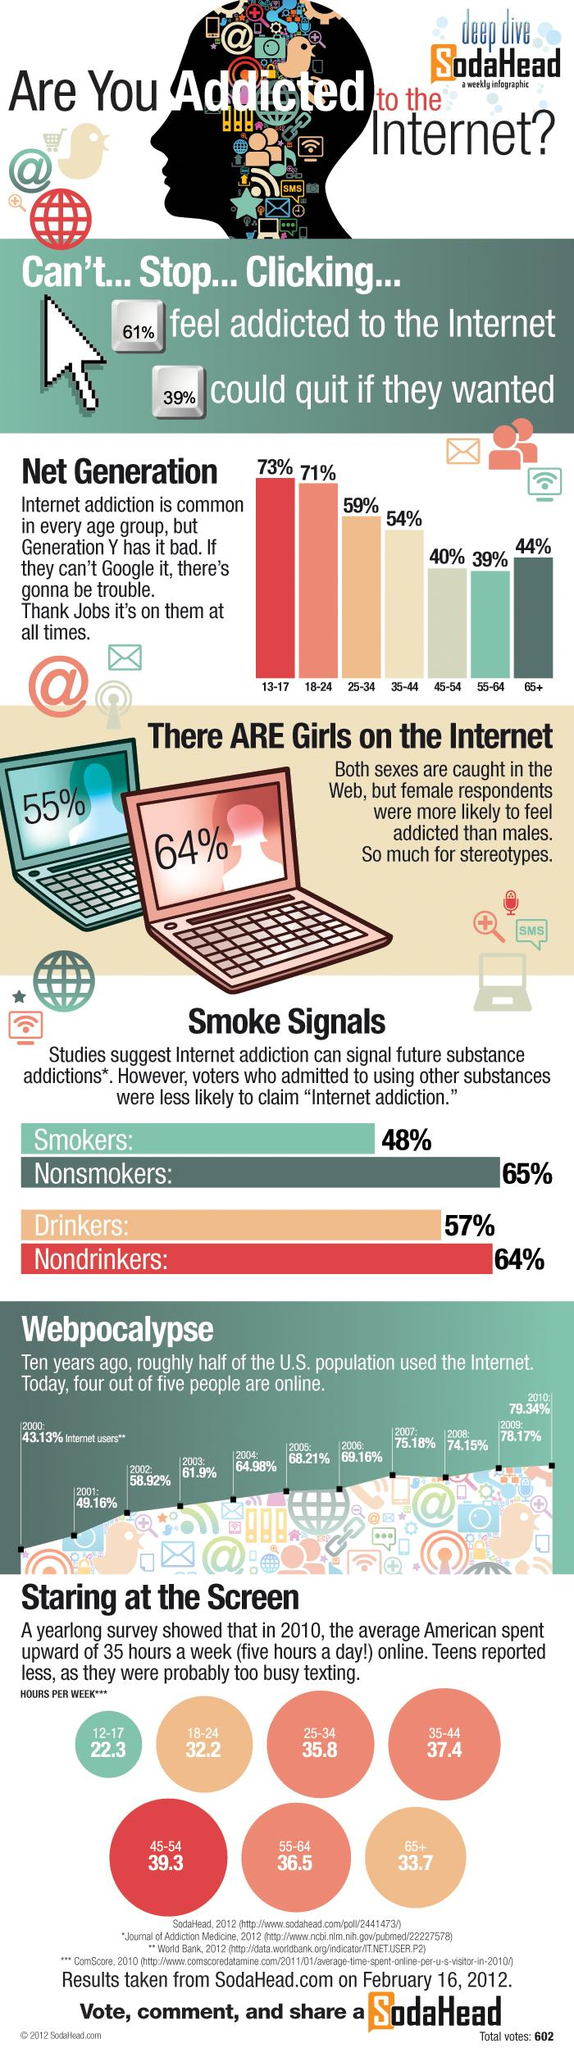Identify some key points in this picture. According to a survey, 61% of people do not want to quit the internet. According to a recent survey, 39% of people believe that they are not addicted to the internet. In the year 2004, approximately 64.98% of the population in the United States used the internet. The 18-24 age group is the second largest group of internet users. The number of hours spent on the internet by the age group 12-17 was 22.3 hours. 